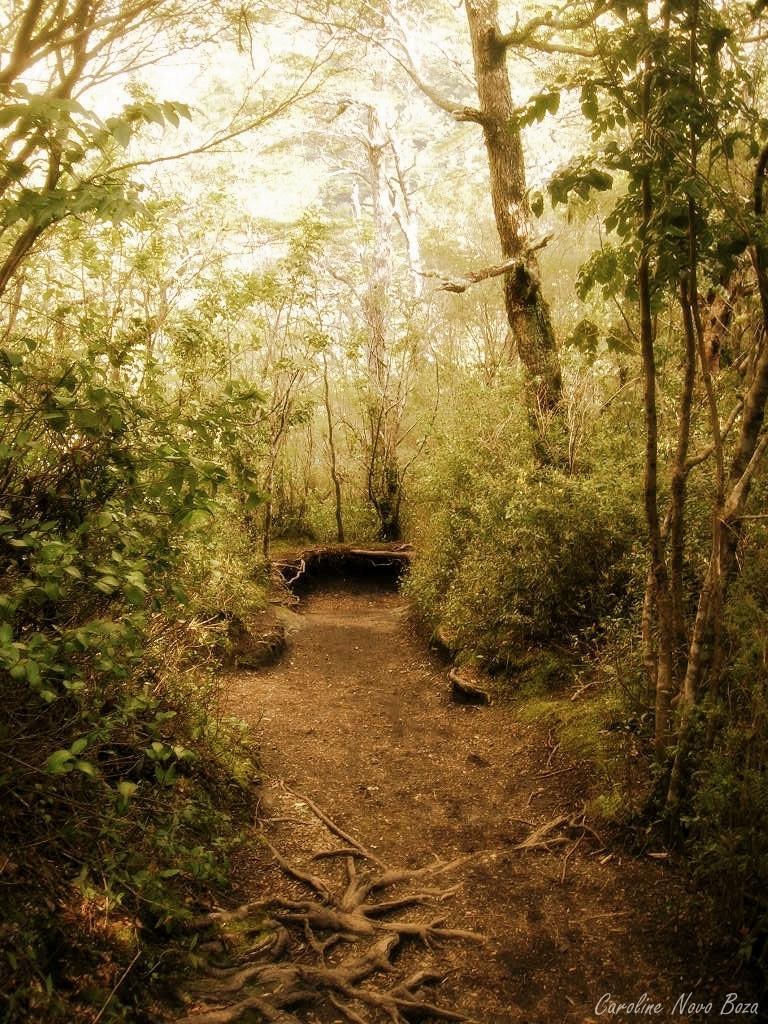Could you give a brief overview of what you see in this image? In this image, we can see so many trees, plants and ground. Right side bottom corner, there is a watermark in the image. 